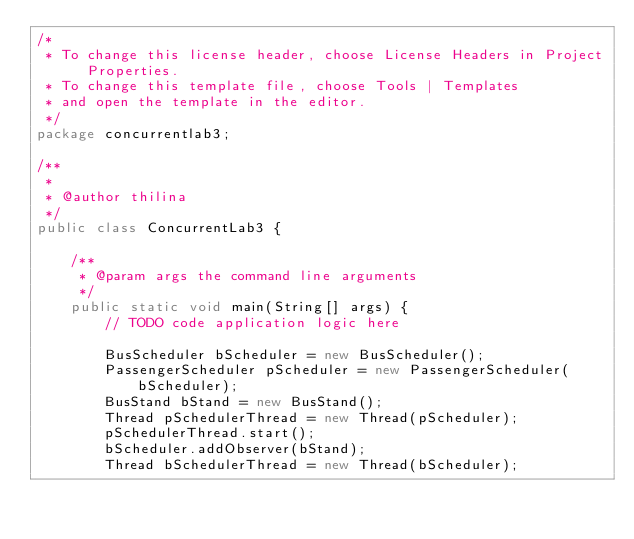<code> <loc_0><loc_0><loc_500><loc_500><_Java_>/*
 * To change this license header, choose License Headers in Project Properties.
 * To change this template file, choose Tools | Templates
 * and open the template in the editor.
 */
package concurrentlab3;

/**
 *
 * @author thilina
 */
public class ConcurrentLab3 {

    /**
     * @param args the command line arguments
     */
    public static void main(String[] args) {
        // TODO code application logic here
        
        BusScheduler bScheduler = new BusScheduler();
        PassengerScheduler pScheduler = new PassengerScheduler(bScheduler);
        BusStand bStand = new BusStand();
        Thread pSchedulerThread = new Thread(pScheduler);
        pSchedulerThread.start();
        bScheduler.addObserver(bStand);
        Thread bSchedulerThread = new Thread(bScheduler);</code> 